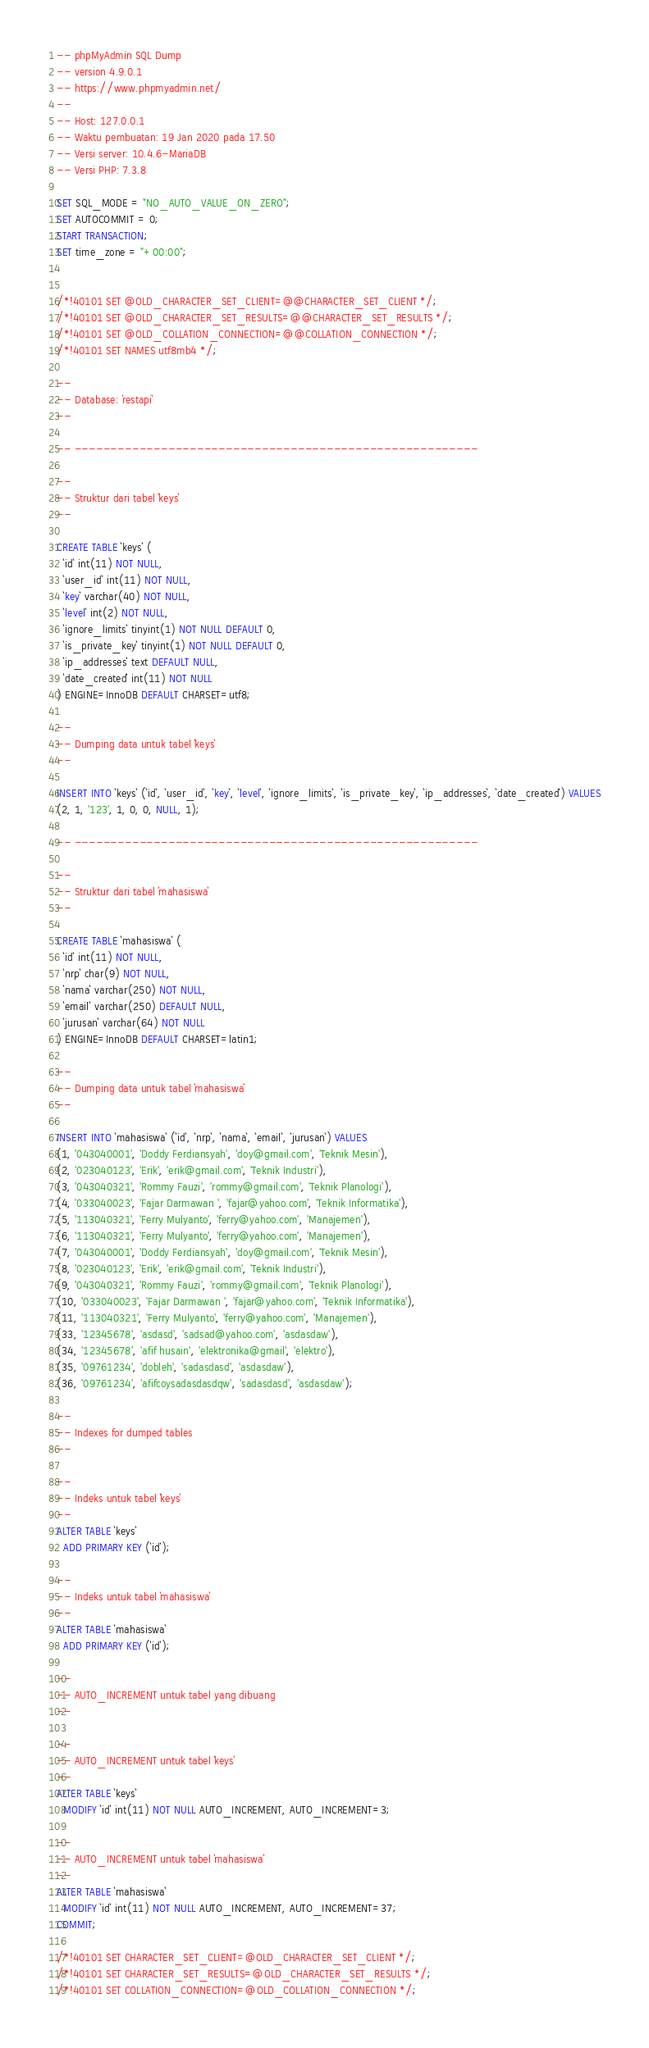<code> <loc_0><loc_0><loc_500><loc_500><_SQL_>-- phpMyAdmin SQL Dump
-- version 4.9.0.1
-- https://www.phpmyadmin.net/
--
-- Host: 127.0.0.1
-- Waktu pembuatan: 19 Jan 2020 pada 17.50
-- Versi server: 10.4.6-MariaDB
-- Versi PHP: 7.3.8

SET SQL_MODE = "NO_AUTO_VALUE_ON_ZERO";
SET AUTOCOMMIT = 0;
START TRANSACTION;
SET time_zone = "+00:00";


/*!40101 SET @OLD_CHARACTER_SET_CLIENT=@@CHARACTER_SET_CLIENT */;
/*!40101 SET @OLD_CHARACTER_SET_RESULTS=@@CHARACTER_SET_RESULTS */;
/*!40101 SET @OLD_COLLATION_CONNECTION=@@COLLATION_CONNECTION */;
/*!40101 SET NAMES utf8mb4 */;

--
-- Database: `restapi`
--

-- --------------------------------------------------------

--
-- Struktur dari tabel `keys`
--

CREATE TABLE `keys` (
  `id` int(11) NOT NULL,
  `user_id` int(11) NOT NULL,
  `key` varchar(40) NOT NULL,
  `level` int(2) NOT NULL,
  `ignore_limits` tinyint(1) NOT NULL DEFAULT 0,
  `is_private_key` tinyint(1) NOT NULL DEFAULT 0,
  `ip_addresses` text DEFAULT NULL,
  `date_created` int(11) NOT NULL
) ENGINE=InnoDB DEFAULT CHARSET=utf8;

--
-- Dumping data untuk tabel `keys`
--

INSERT INTO `keys` (`id`, `user_id`, `key`, `level`, `ignore_limits`, `is_private_key`, `ip_addresses`, `date_created`) VALUES
(2, 1, '123', 1, 0, 0, NULL, 1);

-- --------------------------------------------------------

--
-- Struktur dari tabel `mahasiswa`
--

CREATE TABLE `mahasiswa` (
  `id` int(11) NOT NULL,
  `nrp` char(9) NOT NULL,
  `nama` varchar(250) NOT NULL,
  `email` varchar(250) DEFAULT NULL,
  `jurusan` varchar(64) NOT NULL
) ENGINE=InnoDB DEFAULT CHARSET=latin1;

--
-- Dumping data untuk tabel `mahasiswa`
--

INSERT INTO `mahasiswa` (`id`, `nrp`, `nama`, `email`, `jurusan`) VALUES
(1, '043040001', 'Doddy Ferdiansyah', 'doy@gmail.com', 'Teknik Mesin'),
(2, '023040123', 'Erik', 'erik@gmail.com', 'Teknik Industri'),
(3, '043040321', 'Rommy Fauzi', 'rommy@gmail.com', 'Teknik Planologi'),
(4, '033040023', 'Fajar Darmawan ', 'fajar@yahoo.com', 'Teknik Informatika'),
(5, '113040321', 'Ferry Mulyanto', 'ferry@yahoo.com', 'Manajemen'),
(6, '113040321', 'Ferry Mulyanto', 'ferry@yahoo.com', 'Manajemen'),
(7, '043040001', 'Doddy Ferdiansyah', 'doy@gmail.com', 'Teknik Mesin'),
(8, '023040123', 'Erik', 'erik@gmail.com', 'Teknik Industri'),
(9, '043040321', 'Rommy Fauzi', 'rommy@gmail.com', 'Teknik Planologi'),
(10, '033040023', 'Fajar Darmawan ', 'fajar@yahoo.com', 'Teknik Informatika'),
(11, '113040321', 'Ferry Mulyanto', 'ferry@yahoo.com', 'Manajemen'),
(33, '12345678', 'asdasd', 'sadsad@yahoo.com', 'asdasdaw'),
(34, '12345678', 'afif husain', 'elektronika@gmail', 'elektro'),
(35, '09761234', 'dobleh', 'sadasdasd', 'asdasdaw'),
(36, '09761234', 'afifcoysadasdasdqw', 'sadasdasd', 'asdasdaw');

--
-- Indexes for dumped tables
--

--
-- Indeks untuk tabel `keys`
--
ALTER TABLE `keys`
  ADD PRIMARY KEY (`id`);

--
-- Indeks untuk tabel `mahasiswa`
--
ALTER TABLE `mahasiswa`
  ADD PRIMARY KEY (`id`);

--
-- AUTO_INCREMENT untuk tabel yang dibuang
--

--
-- AUTO_INCREMENT untuk tabel `keys`
--
ALTER TABLE `keys`
  MODIFY `id` int(11) NOT NULL AUTO_INCREMENT, AUTO_INCREMENT=3;

--
-- AUTO_INCREMENT untuk tabel `mahasiswa`
--
ALTER TABLE `mahasiswa`
  MODIFY `id` int(11) NOT NULL AUTO_INCREMENT, AUTO_INCREMENT=37;
COMMIT;

/*!40101 SET CHARACTER_SET_CLIENT=@OLD_CHARACTER_SET_CLIENT */;
/*!40101 SET CHARACTER_SET_RESULTS=@OLD_CHARACTER_SET_RESULTS */;
/*!40101 SET COLLATION_CONNECTION=@OLD_COLLATION_CONNECTION */;
</code> 